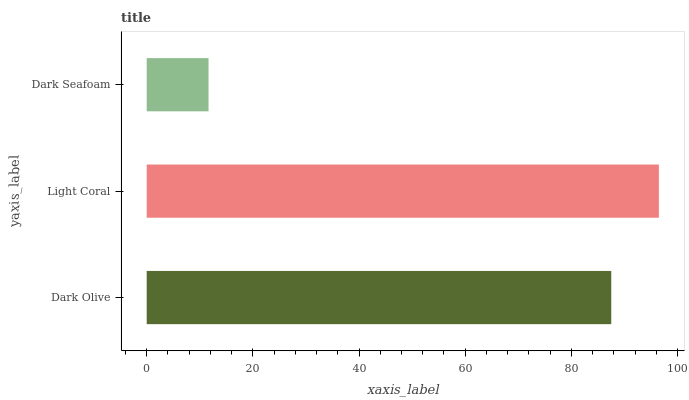Is Dark Seafoam the minimum?
Answer yes or no. Yes. Is Light Coral the maximum?
Answer yes or no. Yes. Is Light Coral the minimum?
Answer yes or no. No. Is Dark Seafoam the maximum?
Answer yes or no. No. Is Light Coral greater than Dark Seafoam?
Answer yes or no. Yes. Is Dark Seafoam less than Light Coral?
Answer yes or no. Yes. Is Dark Seafoam greater than Light Coral?
Answer yes or no. No. Is Light Coral less than Dark Seafoam?
Answer yes or no. No. Is Dark Olive the high median?
Answer yes or no. Yes. Is Dark Olive the low median?
Answer yes or no. Yes. Is Light Coral the high median?
Answer yes or no. No. Is Dark Seafoam the low median?
Answer yes or no. No. 